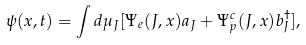Convert formula to latex. <formula><loc_0><loc_0><loc_500><loc_500>\psi ( x , t ) = \int d \mu _ { J } [ \Psi _ { e } ( J , x ) a _ { J } + \Psi _ { p } ^ { c } ( J , x ) b _ { J } ^ { \dagger } ] ,</formula> 